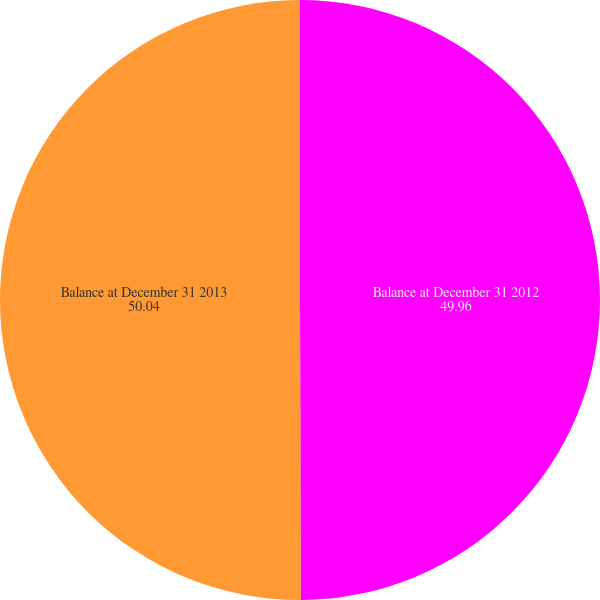<chart> <loc_0><loc_0><loc_500><loc_500><pie_chart><fcel>Balance at December 31 2012<fcel>Balance at December 31 2013<nl><fcel>49.96%<fcel>50.04%<nl></chart> 